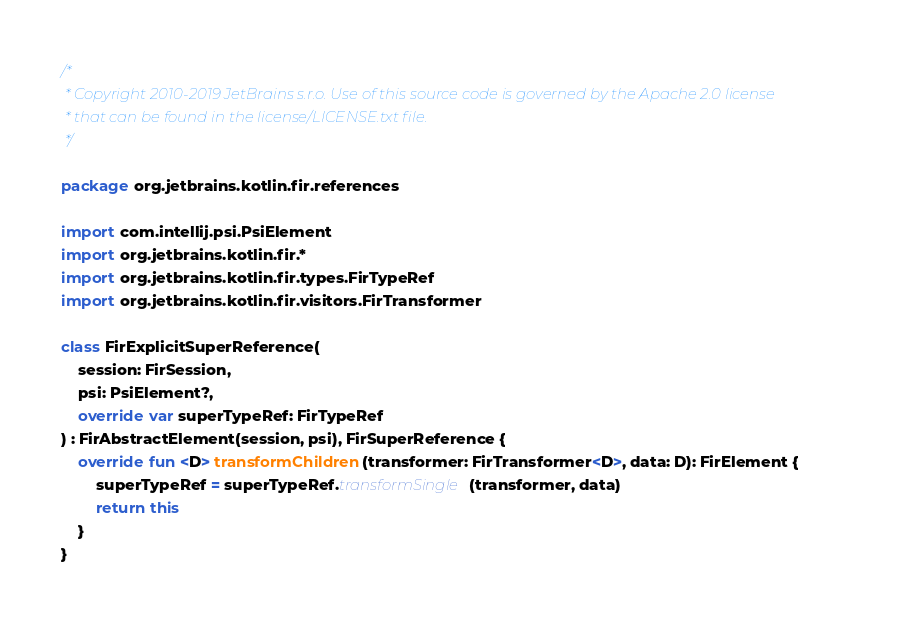<code> <loc_0><loc_0><loc_500><loc_500><_Kotlin_>/*
 * Copyright 2010-2019 JetBrains s.r.o. Use of this source code is governed by the Apache 2.0 license
 * that can be found in the license/LICENSE.txt file.
 */

package org.jetbrains.kotlin.fir.references

import com.intellij.psi.PsiElement
import org.jetbrains.kotlin.fir.*
import org.jetbrains.kotlin.fir.types.FirTypeRef
import org.jetbrains.kotlin.fir.visitors.FirTransformer

class FirExplicitSuperReference(
    session: FirSession,
    psi: PsiElement?,
    override var superTypeRef: FirTypeRef
) : FirAbstractElement(session, psi), FirSuperReference {
    override fun <D> transformChildren(transformer: FirTransformer<D>, data: D): FirElement {
        superTypeRef = superTypeRef.transformSingle(transformer, data)
        return this
    }
}</code> 